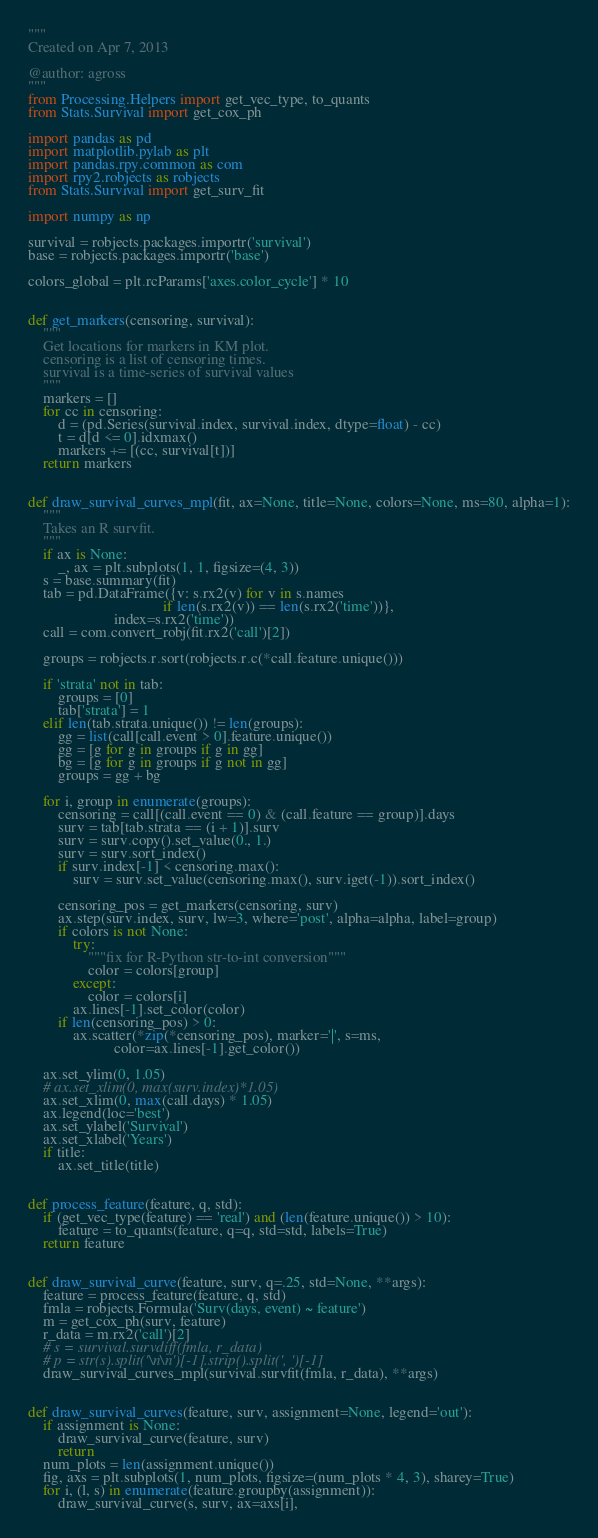Convert code to text. <code><loc_0><loc_0><loc_500><loc_500><_Python_>"""
Created on Apr 7, 2013

@author: agross
"""
from Processing.Helpers import get_vec_type, to_quants
from Stats.Survival import get_cox_ph

import pandas as pd
import matplotlib.pylab as plt
import pandas.rpy.common as com
import rpy2.robjects as robjects 
from Stats.Survival import get_surv_fit

import numpy as np

survival = robjects.packages.importr('survival')
base = robjects.packages.importr('base')

colors_global = plt.rcParams['axes.color_cycle'] * 10


def get_markers(censoring, survival):
    """
    Get locations for markers in KM plot.
    censoring is a list of censoring times.
    survival is a time-series of survival values
    """
    markers = []
    for cc in censoring:
        d = (pd.Series(survival.index, survival.index, dtype=float) - cc)
        t = d[d <= 0].idxmax()
        markers += [(cc, survival[t])]
    return markers


def draw_survival_curves_mpl(fit, ax=None, title=None, colors=None, ms=80, alpha=1):
    """
    Takes an R survfit.
    """
    if ax is None:
        _, ax = plt.subplots(1, 1, figsize=(4, 3))
    s = base.summary(fit)
    tab = pd.DataFrame({v: s.rx2(v) for v in s.names 
                                    if len(s.rx2(v)) == len(s.rx2('time'))},
                       index=s.rx2('time'))
    call = com.convert_robj(fit.rx2('call')[2])
    
    groups = robjects.r.sort(robjects.r.c(*call.feature.unique()))
    
    if 'strata' not in tab:
        groups = [0]
        tab['strata'] = 1
    elif len(tab.strata.unique()) != len(groups):
        gg = list(call[call.event > 0].feature.unique())
        gg = [g for g in groups if g in gg]
        bg = [g for g in groups if g not in gg]
        groups = gg + bg
           
    for i, group in enumerate(groups):
        censoring = call[(call.event == 0) & (call.feature == group)].days
        surv = tab[tab.strata == (i + 1)].surv
        surv = surv.copy().set_value(0., 1.)
        surv = surv.sort_index()
        if surv.index[-1] < censoring.max():
            surv = surv.set_value(censoring.max(), surv.iget(-1)).sort_index()

        censoring_pos = get_markers(censoring, surv)
        ax.step(surv.index, surv, lw=3, where='post', alpha=alpha, label=group)
        if colors is not None:
            try:
                """fix for R-Python str-to-int conversion"""
                color = colors[group]
            except:
                color = colors[i]
            ax.lines[-1].set_color(color)
        if len(censoring_pos) > 0:
            ax.scatter(*zip(*censoring_pos), marker='|', s=ms,
                       color=ax.lines[-1].get_color())
        
    ax.set_ylim(0, 1.05)
    # ax.set_xlim(0, max(surv.index)*1.05)
    ax.set_xlim(0, max(call.days) * 1.05)
    ax.legend(loc='best')
    ax.set_ylabel('Survival')
    ax.set_xlabel('Years')
    if title:
        ax.set_title(title)


def process_feature(feature, q, std):
    if (get_vec_type(feature) == 'real') and (len(feature.unique()) > 10):
        feature = to_quants(feature, q=q, std=std, labels=True)
    return feature


def draw_survival_curve(feature, surv, q=.25, std=None, **args):
    feature = process_feature(feature, q, std)
    fmla = robjects.Formula('Surv(days, event) ~ feature')           
    m = get_cox_ph(surv, feature)
    r_data = m.rx2('call')[2]
    # s = survival.survdiff(fmla, r_data)
    # p = str(s).split('\n\n')[-1].strip().split(', ')[-1]
    draw_survival_curves_mpl(survival.survfit(fmla, r_data), **args)


def draw_survival_curves(feature, surv, assignment=None, legend='out'):
    if assignment is None:
        draw_survival_curve(feature, surv)
        return
    num_plots = len(assignment.unique())
    fig, axs = plt.subplots(1, num_plots, figsize=(num_plots * 4, 3), sharey=True)
    for i, (l, s) in enumerate(feature.groupby(assignment)):
        draw_survival_curve(s, surv, ax=axs[i],</code> 